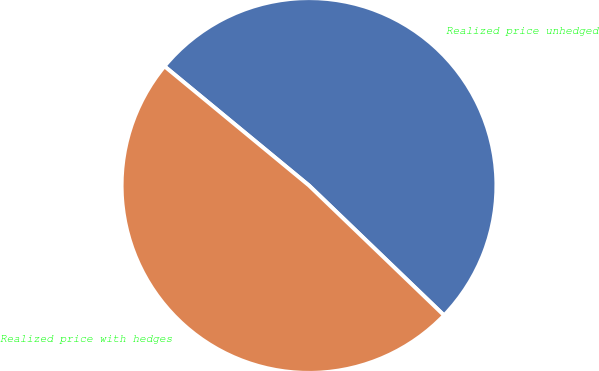<chart> <loc_0><loc_0><loc_500><loc_500><pie_chart><fcel>Realized price unhedged<fcel>Realized price with hedges<nl><fcel>51.21%<fcel>48.79%<nl></chart> 